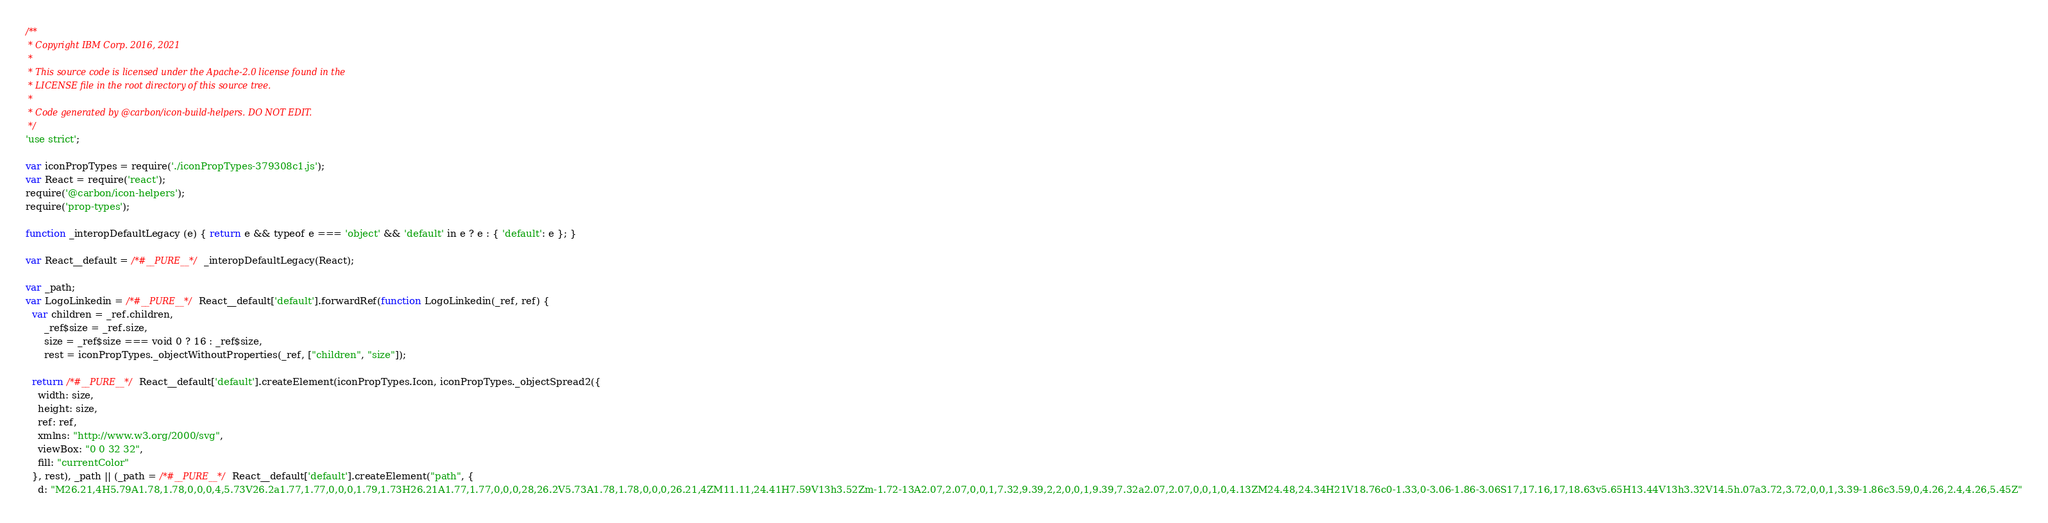<code> <loc_0><loc_0><loc_500><loc_500><_JavaScript_>/**
 * Copyright IBM Corp. 2016, 2021
 *
 * This source code is licensed under the Apache-2.0 license found in the
 * LICENSE file in the root directory of this source tree.
 *
 * Code generated by @carbon/icon-build-helpers. DO NOT EDIT.
 */
'use strict';

var iconPropTypes = require('./iconPropTypes-379308c1.js');
var React = require('react');
require('@carbon/icon-helpers');
require('prop-types');

function _interopDefaultLegacy (e) { return e && typeof e === 'object' && 'default' in e ? e : { 'default': e }; }

var React__default = /*#__PURE__*/_interopDefaultLegacy(React);

var _path;
var LogoLinkedin = /*#__PURE__*/React__default['default'].forwardRef(function LogoLinkedin(_ref, ref) {
  var children = _ref.children,
      _ref$size = _ref.size,
      size = _ref$size === void 0 ? 16 : _ref$size,
      rest = iconPropTypes._objectWithoutProperties(_ref, ["children", "size"]);

  return /*#__PURE__*/React__default['default'].createElement(iconPropTypes.Icon, iconPropTypes._objectSpread2({
    width: size,
    height: size,
    ref: ref,
    xmlns: "http://www.w3.org/2000/svg",
    viewBox: "0 0 32 32",
    fill: "currentColor"
  }, rest), _path || (_path = /*#__PURE__*/React__default['default'].createElement("path", {
    d: "M26.21,4H5.79A1.78,1.78,0,0,0,4,5.73V26.2a1.77,1.77,0,0,0,1.79,1.73H26.21A1.77,1.77,0,0,0,28,26.2V5.73A1.78,1.78,0,0,0,26.21,4ZM11.11,24.41H7.59V13h3.52Zm-1.72-13A2.07,2.07,0,0,1,7.32,9.39,2,2,0,0,1,9.39,7.32a2.07,2.07,0,0,1,0,4.13ZM24.48,24.34H21V18.76c0-1.33,0-3.06-1.86-3.06S17,17.16,17,18.63v5.65H13.44V13h3.32V14.5h.07a3.72,3.72,0,0,1,3.39-1.86c3.59,0,4.26,2.4,4.26,5.45Z"</code> 